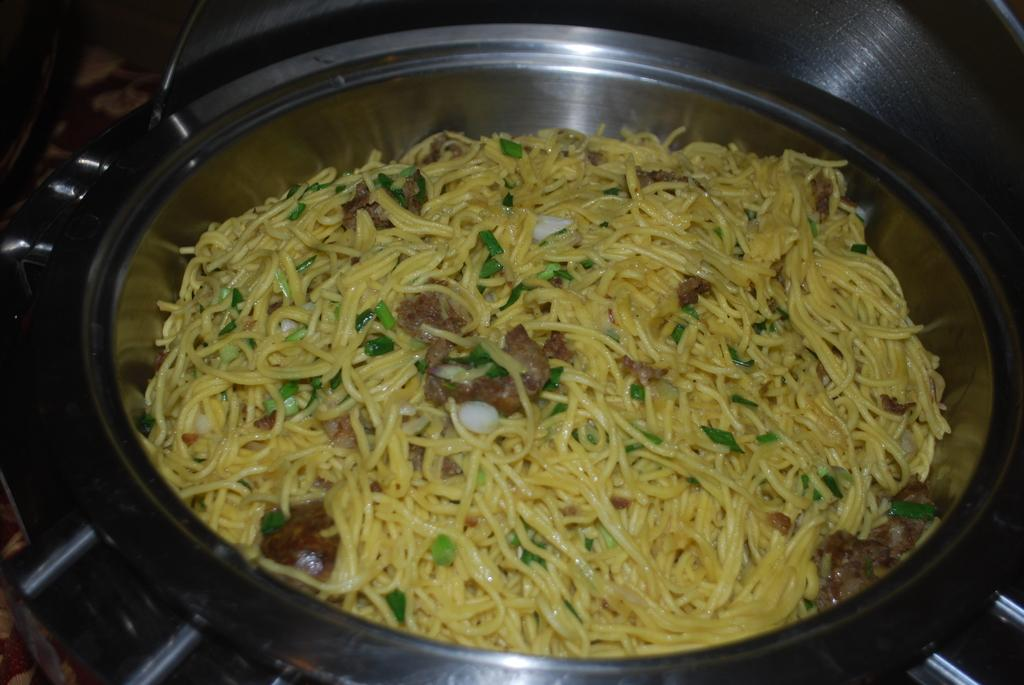What is in the bowl that is visible in the center of the image? There is a bowl of noodles in the image. What type of treatment is being administered to the cattle in the image? There are no cattle present in the image, and therefore no treatment is being administered. What is the oven used for in the image? There is no oven present in the image. 